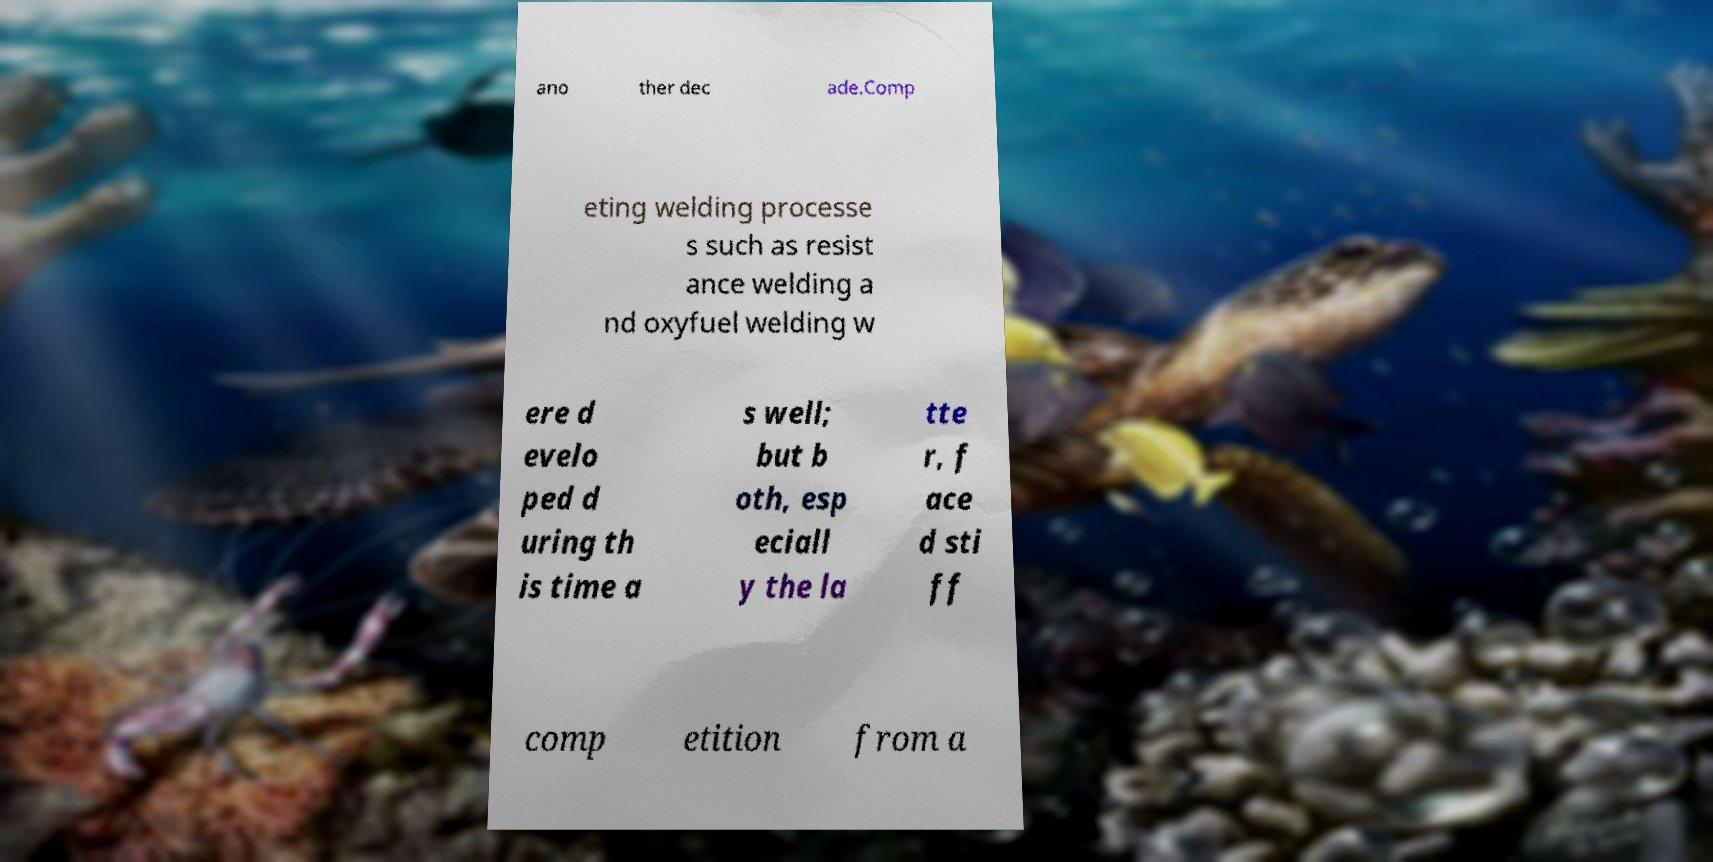Please read and relay the text visible in this image. What does it say? ano ther dec ade.Comp eting welding processe s such as resist ance welding a nd oxyfuel welding w ere d evelo ped d uring th is time a s well; but b oth, esp eciall y the la tte r, f ace d sti ff comp etition from a 